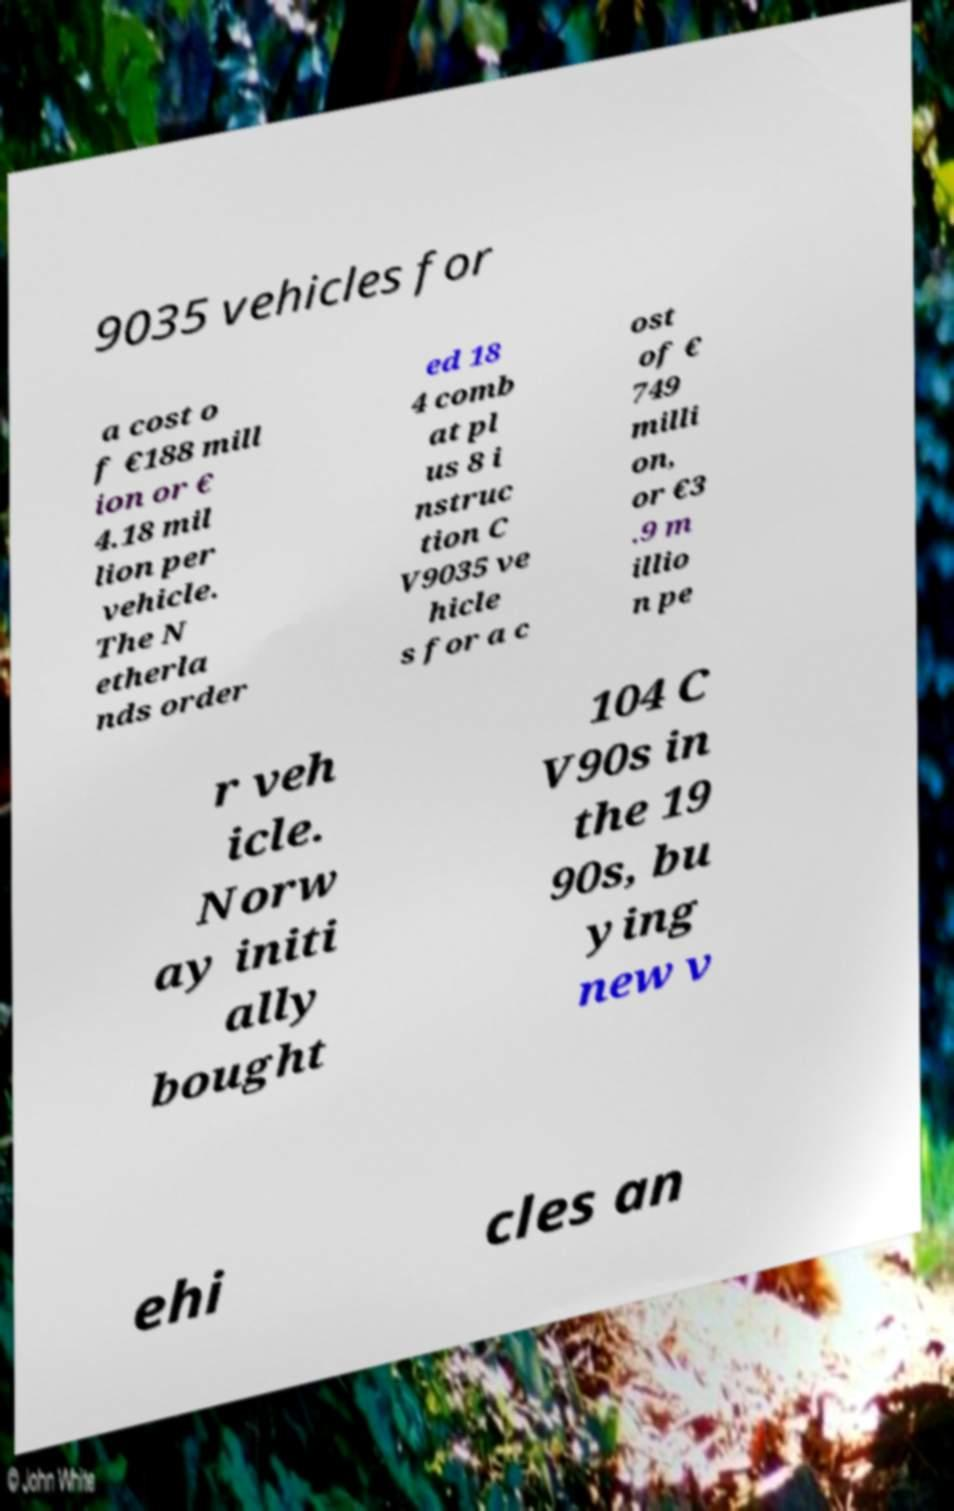Please read and relay the text visible in this image. What does it say? 9035 vehicles for a cost o f €188 mill ion or € 4.18 mil lion per vehicle. The N etherla nds order ed 18 4 comb at pl us 8 i nstruc tion C V9035 ve hicle s for a c ost of € 749 milli on, or €3 .9 m illio n pe r veh icle. Norw ay initi ally bought 104 C V90s in the 19 90s, bu ying new v ehi cles an 